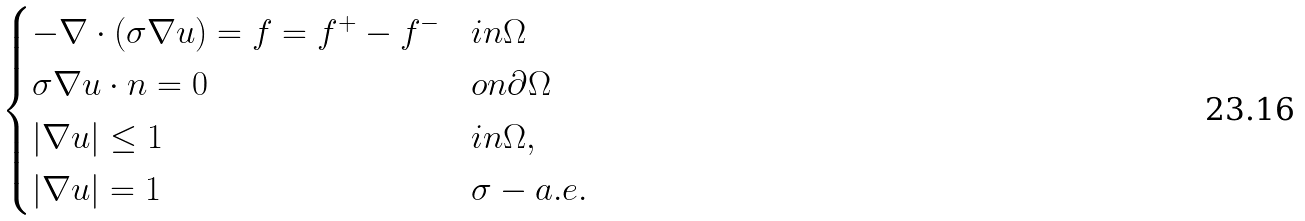Convert formula to latex. <formula><loc_0><loc_0><loc_500><loc_500>\begin{cases} - \nabla \cdot ( \sigma \nabla u ) = f = f ^ { + } - f ^ { - } & i n \Omega \\ \sigma \nabla u \cdot n = 0 & o n \partial \Omega \\ | \nabla u | \leq 1 & i n \Omega , \\ | \nabla u | = 1 & \sigma - a . e . \end{cases}</formula> 